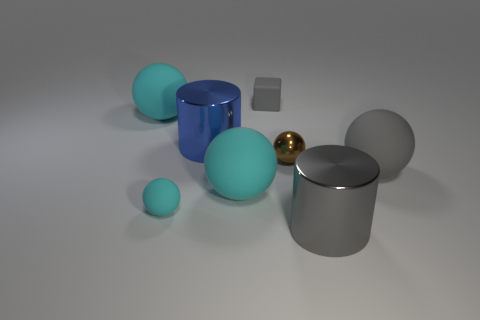What shape is the large metal object that is the same color as the rubber block?
Your answer should be very brief. Cylinder. There is a cylinder that is behind the tiny shiny sphere; does it have the same color as the small sphere that is left of the blue metal cylinder?
Offer a terse response. No. There is a big gray metal thing; what number of matte blocks are right of it?
Provide a succinct answer. 0. What size is the metallic cylinder that is the same color as the small block?
Ensure brevity in your answer.  Large. Is there a big red shiny thing that has the same shape as the small brown thing?
Keep it short and to the point. No. There is a shiny cylinder that is the same size as the gray metallic object; what color is it?
Provide a short and direct response. Blue. Are there fewer big things that are to the right of the small cube than small things to the left of the small brown sphere?
Give a very brief answer. No. There is a metal cylinder in front of the metallic ball; is its size the same as the small gray cube?
Make the answer very short. No. There is a shiny thing in front of the tiny cyan ball; what is its shape?
Provide a short and direct response. Cylinder. Are there more tiny brown things than balls?
Make the answer very short. No. 